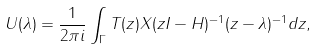<formula> <loc_0><loc_0><loc_500><loc_500>U ( \lambda ) = \frac { 1 } { 2 \pi i } \int _ { \Gamma } T ( z ) X ( z I - H ) ^ { - 1 } ( z - \lambda ) ^ { - 1 } d z ,</formula> 